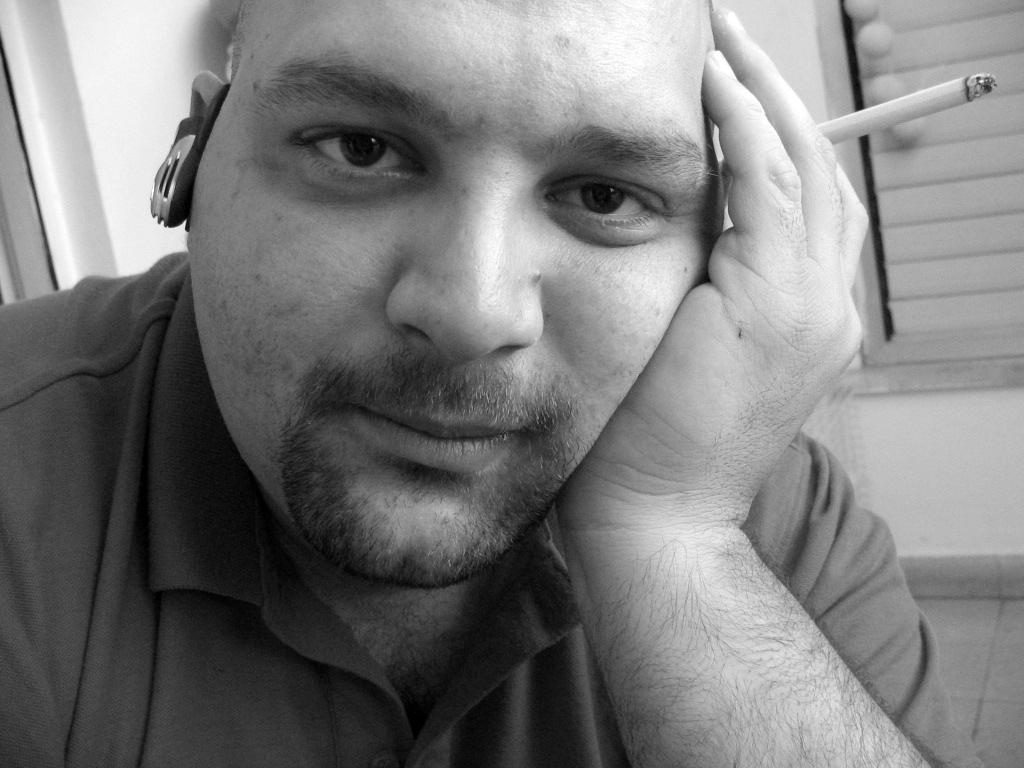What is the man in the image doing? The man is seated in the image. What is the man holding in his hand? The man is holding a cigarette in his hand. What can be seen through the window in the image? The facts do not specify what can be seen through the window. What type of apparel are the girls wearing in the image? There are no girls present in the image, only a man seated and holding a cigarette. 